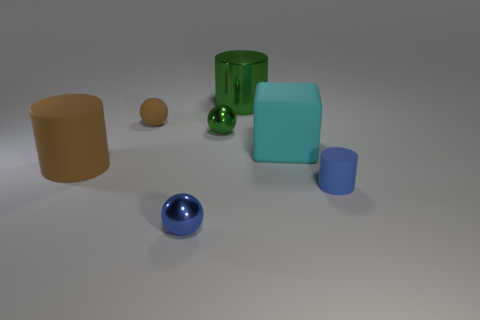If I were to create a real-life still life inspired by this image, what considerations should I take into account? To recreate this still life, consider the balance and arrangement of objects, their colors, materials, and how the light interacts with those materials. You'll want to choose objects with similar shapes and colors for consistency. Pay attention to lighting to ensure it highlights the objects similarly, and think about the surface upon which you place them to achieve a setup that mimics the visual depth and space of the image. 